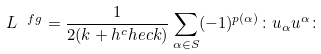<formula> <loc_0><loc_0><loc_500><loc_500>L ^ { \ f g } = \frac { 1 } { 2 ( k + h ^ { c } h e c k ) } \sum _ { \alpha \in S } ( - 1 ) ^ { p ( \alpha ) } \colon u _ { \alpha } u ^ { \alpha } \colon</formula> 